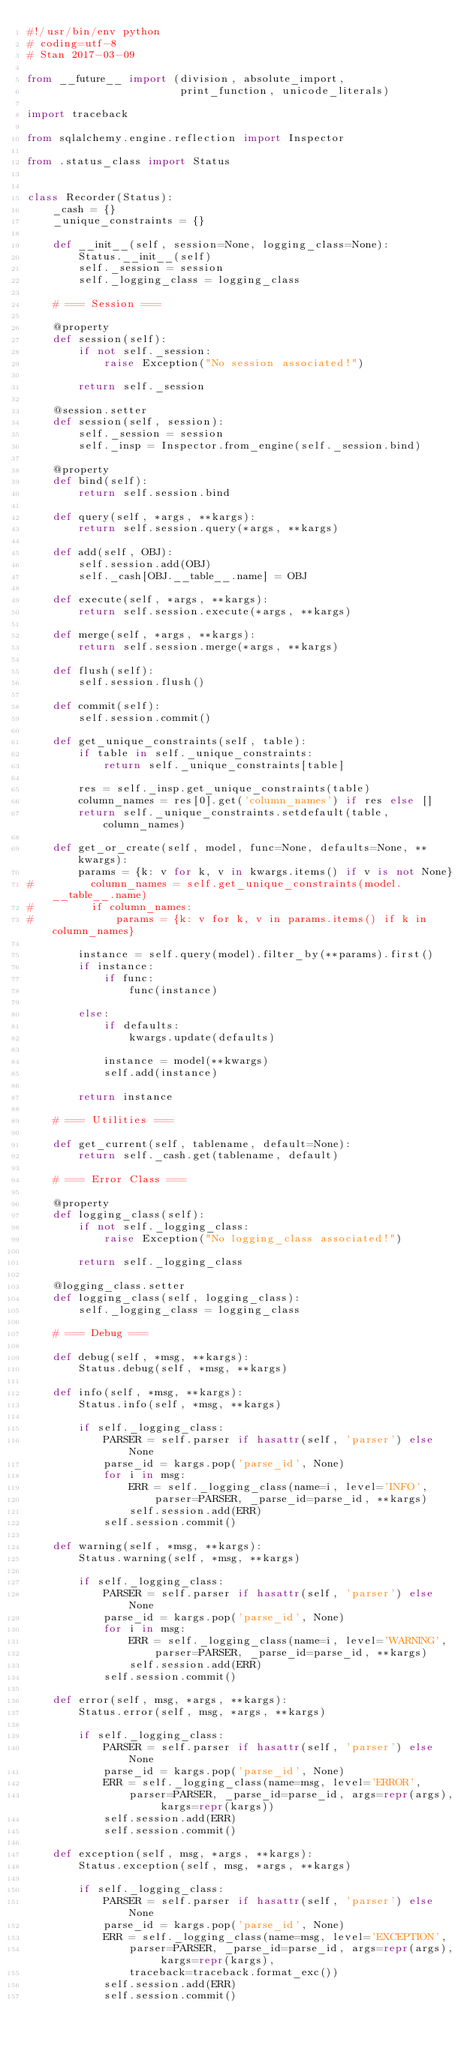<code> <loc_0><loc_0><loc_500><loc_500><_Python_>#!/usr/bin/env python
# coding=utf-8
# Stan 2017-03-09

from __future__ import (division, absolute_import,
                        print_function, unicode_literals)

import traceback

from sqlalchemy.engine.reflection import Inspector

from .status_class import Status


class Recorder(Status):
    _cash = {}
    _unique_constraints = {}

    def __init__(self, session=None, logging_class=None):
        Status.__init__(self)
        self._session = session
        self._logging_class = logging_class

    # === Session ===

    @property
    def session(self):
        if not self._session:
            raise Exception("No session associated!")

        return self._session

    @session.setter
    def session(self, session):
        self._session = session
        self._insp = Inspector.from_engine(self._session.bind)

    @property
    def bind(self):
        return self.session.bind

    def query(self, *args, **kargs):
        return self.session.query(*args, **kargs)

    def add(self, OBJ):
        self.session.add(OBJ)
        self._cash[OBJ.__table__.name] = OBJ

    def execute(self, *args, **kargs):
        return self.session.execute(*args, **kargs)

    def merge(self, *args, **kargs):
        return self.session.merge(*args, **kargs)

    def flush(self):
        self.session.flush()

    def commit(self):
        self.session.commit()

    def get_unique_constraints(self, table):
        if table in self._unique_constraints:
            return self._unique_constraints[table]

        res = self._insp.get_unique_constraints(table)
        column_names = res[0].get('column_names') if res else []
        return self._unique_constraints.setdefault(table, column_names)

    def get_or_create(self, model, func=None, defaults=None, **kwargs):
        params = {k: v for k, v in kwargs.items() if v is not None}
#         column_names = self.get_unique_constraints(model.__table__.name)
#         if column_names:
#             params = {k: v for k, v in params.items() if k in column_names}

        instance = self.query(model).filter_by(**params).first()
        if instance:
            if func:
                func(instance)

        else:
            if defaults:
                kwargs.update(defaults)

            instance = model(**kwargs)
            self.add(instance)

        return instance

    # === Utilities ===

    def get_current(self, tablename, default=None):
        return self._cash.get(tablename, default)

    # === Error Class ===

    @property
    def logging_class(self):
        if not self._logging_class:
            raise Exception("No logging_class associated!")

        return self._logging_class

    @logging_class.setter
    def logging_class(self, logging_class):
        self._logging_class = logging_class

    # === Debug ===

    def debug(self, *msg, **kargs):
        Status.debug(self, *msg, **kargs)

    def info(self, *msg, **kargs):
        Status.info(self, *msg, **kargs)

        if self._logging_class:
            PARSER = self.parser if hasattr(self, 'parser') else None
            parse_id = kargs.pop('parse_id', None)
            for i in msg:
                ERR = self._logging_class(name=i, level='INFO',
                    parser=PARSER, _parse_id=parse_id, **kargs)
                self.session.add(ERR)
            self.session.commit()

    def warning(self, *msg, **kargs):
        Status.warning(self, *msg, **kargs)

        if self._logging_class:
            PARSER = self.parser if hasattr(self, 'parser') else None
            parse_id = kargs.pop('parse_id', None)
            for i in msg:
                ERR = self._logging_class(name=i, level='WARNING',
                    parser=PARSER, _parse_id=parse_id, **kargs)
                self.session.add(ERR)
            self.session.commit()

    def error(self, msg, *args, **kargs):
        Status.error(self, msg, *args, **kargs)

        if self._logging_class:
            PARSER = self.parser if hasattr(self, 'parser') else None
            parse_id = kargs.pop('parse_id', None)
            ERR = self._logging_class(name=msg, level='ERROR',
                parser=PARSER, _parse_id=parse_id, args=repr(args), kargs=repr(kargs))
            self.session.add(ERR)
            self.session.commit()

    def exception(self, msg, *args, **kargs):
        Status.exception(self, msg, *args, **kargs)

        if self._logging_class:
            PARSER = self.parser if hasattr(self, 'parser') else None
            parse_id = kargs.pop('parse_id', None)
            ERR = self._logging_class(name=msg, level='EXCEPTION',
                parser=PARSER, _parse_id=parse_id, args=repr(args), kargs=repr(kargs),
                traceback=traceback.format_exc())
            self.session.add(ERR)
            self.session.commit()
</code> 